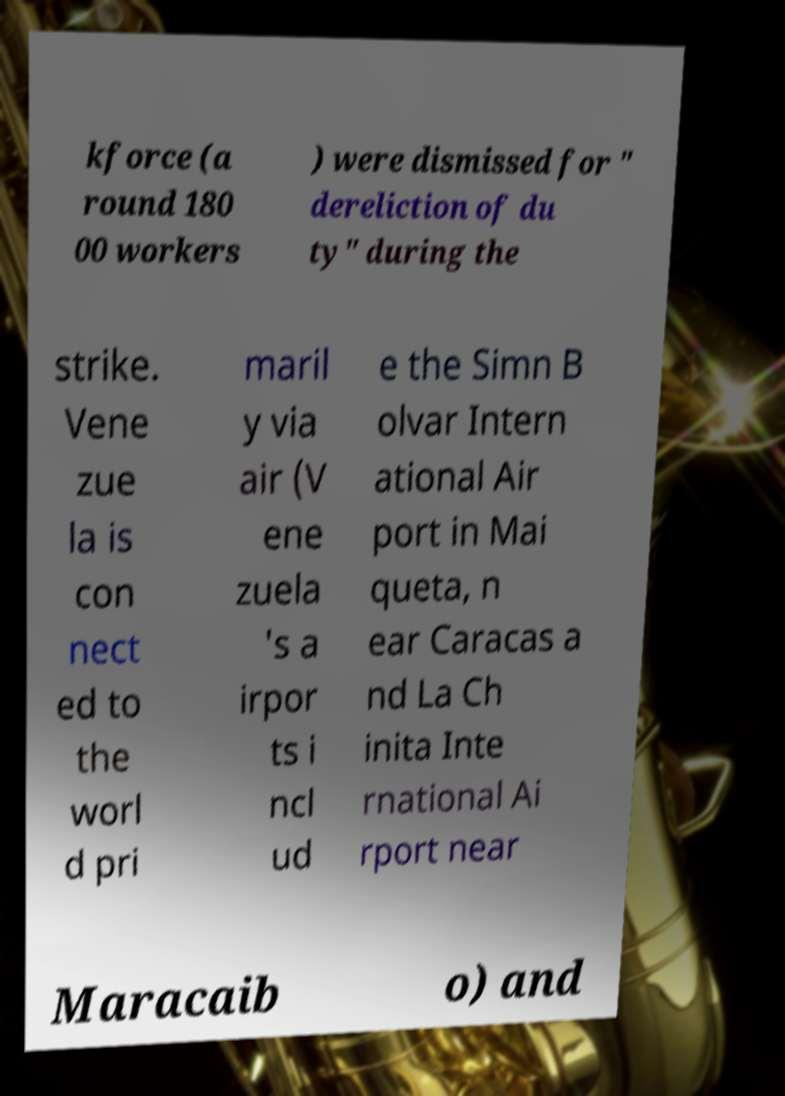Please read and relay the text visible in this image. What does it say? kforce (a round 180 00 workers ) were dismissed for " dereliction of du ty" during the strike. Vene zue la is con nect ed to the worl d pri maril y via air (V ene zuela 's a irpor ts i ncl ud e the Simn B olvar Intern ational Air port in Mai queta, n ear Caracas a nd La Ch inita Inte rnational Ai rport near Maracaib o) and 